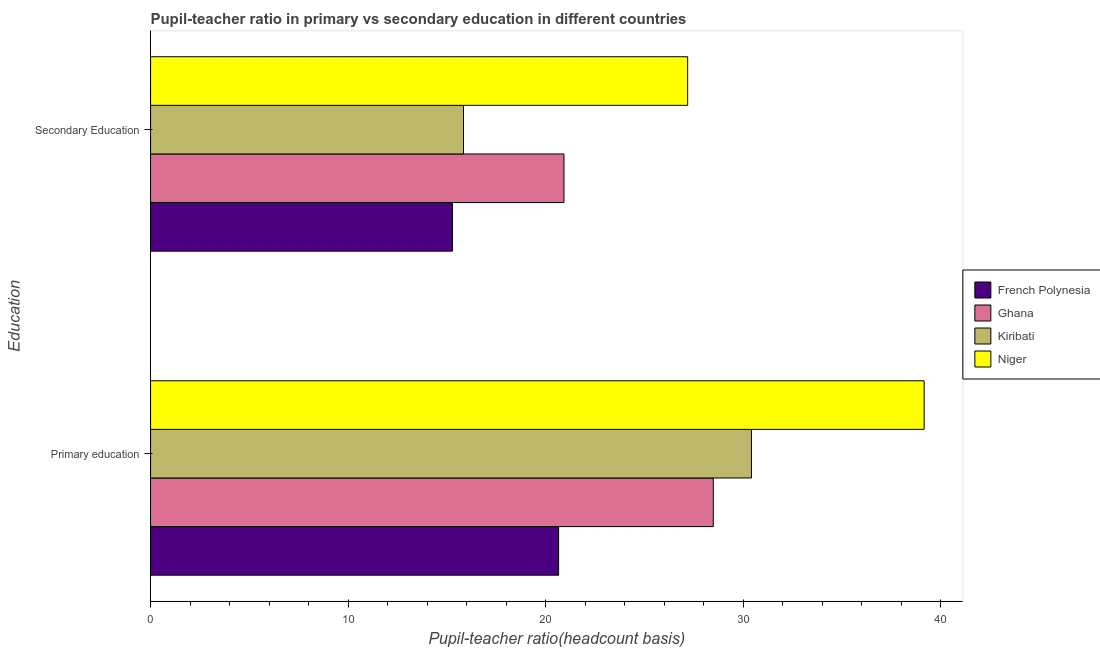How many groups of bars are there?
Provide a short and direct response. 2. Are the number of bars on each tick of the Y-axis equal?
Provide a short and direct response. Yes. How many bars are there on the 1st tick from the top?
Make the answer very short. 4. How many bars are there on the 2nd tick from the bottom?
Give a very brief answer. 4. What is the label of the 2nd group of bars from the top?
Provide a succinct answer. Primary education. What is the pupil-teacher ratio in primary education in Niger?
Give a very brief answer. 39.17. Across all countries, what is the maximum pupil teacher ratio on secondary education?
Your answer should be compact. 27.19. Across all countries, what is the minimum pupil teacher ratio on secondary education?
Offer a terse response. 15.28. In which country was the pupil teacher ratio on secondary education maximum?
Offer a terse response. Niger. In which country was the pupil teacher ratio on secondary education minimum?
Your response must be concise. French Polynesia. What is the total pupil-teacher ratio in primary education in the graph?
Ensure brevity in your answer.  118.75. What is the difference between the pupil-teacher ratio in primary education in French Polynesia and that in Ghana?
Ensure brevity in your answer.  -7.83. What is the difference between the pupil teacher ratio on secondary education in Niger and the pupil-teacher ratio in primary education in Ghana?
Give a very brief answer. -1.3. What is the average pupil-teacher ratio in primary education per country?
Ensure brevity in your answer.  29.69. What is the difference between the pupil-teacher ratio in primary education and pupil teacher ratio on secondary education in Kiribati?
Give a very brief answer. 14.58. What is the ratio of the pupil teacher ratio on secondary education in French Polynesia to that in Niger?
Offer a terse response. 0.56. Is the pupil-teacher ratio in primary education in Kiribati less than that in Niger?
Offer a very short reply. Yes. What does the 1st bar from the bottom in Secondary Education represents?
Give a very brief answer. French Polynesia. What is the difference between two consecutive major ticks on the X-axis?
Offer a very short reply. 10. How many legend labels are there?
Provide a succinct answer. 4. How are the legend labels stacked?
Make the answer very short. Vertical. What is the title of the graph?
Offer a very short reply. Pupil-teacher ratio in primary vs secondary education in different countries. Does "Europe(all income levels)" appear as one of the legend labels in the graph?
Provide a succinct answer. No. What is the label or title of the X-axis?
Make the answer very short. Pupil-teacher ratio(headcount basis). What is the label or title of the Y-axis?
Make the answer very short. Education. What is the Pupil-teacher ratio(headcount basis) in French Polynesia in Primary education?
Your answer should be compact. 20.66. What is the Pupil-teacher ratio(headcount basis) in Ghana in Primary education?
Keep it short and to the point. 28.49. What is the Pupil-teacher ratio(headcount basis) of Kiribati in Primary education?
Your answer should be very brief. 30.43. What is the Pupil-teacher ratio(headcount basis) of Niger in Primary education?
Your answer should be compact. 39.17. What is the Pupil-teacher ratio(headcount basis) of French Polynesia in Secondary Education?
Offer a very short reply. 15.28. What is the Pupil-teacher ratio(headcount basis) of Ghana in Secondary Education?
Your answer should be compact. 20.93. What is the Pupil-teacher ratio(headcount basis) in Kiribati in Secondary Education?
Offer a very short reply. 15.84. What is the Pupil-teacher ratio(headcount basis) in Niger in Secondary Education?
Offer a terse response. 27.19. Across all Education, what is the maximum Pupil-teacher ratio(headcount basis) of French Polynesia?
Provide a succinct answer. 20.66. Across all Education, what is the maximum Pupil-teacher ratio(headcount basis) in Ghana?
Your response must be concise. 28.49. Across all Education, what is the maximum Pupil-teacher ratio(headcount basis) in Kiribati?
Provide a short and direct response. 30.43. Across all Education, what is the maximum Pupil-teacher ratio(headcount basis) of Niger?
Your answer should be very brief. 39.17. Across all Education, what is the minimum Pupil-teacher ratio(headcount basis) in French Polynesia?
Offer a terse response. 15.28. Across all Education, what is the minimum Pupil-teacher ratio(headcount basis) in Ghana?
Your response must be concise. 20.93. Across all Education, what is the minimum Pupil-teacher ratio(headcount basis) of Kiribati?
Your response must be concise. 15.84. Across all Education, what is the minimum Pupil-teacher ratio(headcount basis) of Niger?
Provide a short and direct response. 27.19. What is the total Pupil-teacher ratio(headcount basis) in French Polynesia in the graph?
Your response must be concise. 35.94. What is the total Pupil-teacher ratio(headcount basis) in Ghana in the graph?
Make the answer very short. 49.42. What is the total Pupil-teacher ratio(headcount basis) of Kiribati in the graph?
Make the answer very short. 46.27. What is the total Pupil-teacher ratio(headcount basis) in Niger in the graph?
Give a very brief answer. 66.36. What is the difference between the Pupil-teacher ratio(headcount basis) of French Polynesia in Primary education and that in Secondary Education?
Your answer should be compact. 5.38. What is the difference between the Pupil-teacher ratio(headcount basis) in Ghana in Primary education and that in Secondary Education?
Provide a short and direct response. 7.56. What is the difference between the Pupil-teacher ratio(headcount basis) of Kiribati in Primary education and that in Secondary Education?
Your response must be concise. 14.58. What is the difference between the Pupil-teacher ratio(headcount basis) in Niger in Primary education and that in Secondary Education?
Your response must be concise. 11.97. What is the difference between the Pupil-teacher ratio(headcount basis) in French Polynesia in Primary education and the Pupil-teacher ratio(headcount basis) in Ghana in Secondary Education?
Your answer should be very brief. -0.27. What is the difference between the Pupil-teacher ratio(headcount basis) in French Polynesia in Primary education and the Pupil-teacher ratio(headcount basis) in Kiribati in Secondary Education?
Keep it short and to the point. 4.82. What is the difference between the Pupil-teacher ratio(headcount basis) in French Polynesia in Primary education and the Pupil-teacher ratio(headcount basis) in Niger in Secondary Education?
Your answer should be compact. -6.53. What is the difference between the Pupil-teacher ratio(headcount basis) in Ghana in Primary education and the Pupil-teacher ratio(headcount basis) in Kiribati in Secondary Education?
Your answer should be very brief. 12.65. What is the difference between the Pupil-teacher ratio(headcount basis) in Ghana in Primary education and the Pupil-teacher ratio(headcount basis) in Niger in Secondary Education?
Offer a terse response. 1.3. What is the difference between the Pupil-teacher ratio(headcount basis) in Kiribati in Primary education and the Pupil-teacher ratio(headcount basis) in Niger in Secondary Education?
Your answer should be compact. 3.23. What is the average Pupil-teacher ratio(headcount basis) of French Polynesia per Education?
Make the answer very short. 17.97. What is the average Pupil-teacher ratio(headcount basis) of Ghana per Education?
Your answer should be compact. 24.71. What is the average Pupil-teacher ratio(headcount basis) in Kiribati per Education?
Provide a short and direct response. 23.13. What is the average Pupil-teacher ratio(headcount basis) in Niger per Education?
Offer a terse response. 33.18. What is the difference between the Pupil-teacher ratio(headcount basis) in French Polynesia and Pupil-teacher ratio(headcount basis) in Ghana in Primary education?
Give a very brief answer. -7.83. What is the difference between the Pupil-teacher ratio(headcount basis) in French Polynesia and Pupil-teacher ratio(headcount basis) in Kiribati in Primary education?
Keep it short and to the point. -9.77. What is the difference between the Pupil-teacher ratio(headcount basis) in French Polynesia and Pupil-teacher ratio(headcount basis) in Niger in Primary education?
Offer a very short reply. -18.51. What is the difference between the Pupil-teacher ratio(headcount basis) of Ghana and Pupil-teacher ratio(headcount basis) of Kiribati in Primary education?
Make the answer very short. -1.93. What is the difference between the Pupil-teacher ratio(headcount basis) in Ghana and Pupil-teacher ratio(headcount basis) in Niger in Primary education?
Provide a succinct answer. -10.68. What is the difference between the Pupil-teacher ratio(headcount basis) in Kiribati and Pupil-teacher ratio(headcount basis) in Niger in Primary education?
Make the answer very short. -8.74. What is the difference between the Pupil-teacher ratio(headcount basis) of French Polynesia and Pupil-teacher ratio(headcount basis) of Ghana in Secondary Education?
Provide a succinct answer. -5.65. What is the difference between the Pupil-teacher ratio(headcount basis) of French Polynesia and Pupil-teacher ratio(headcount basis) of Kiribati in Secondary Education?
Keep it short and to the point. -0.56. What is the difference between the Pupil-teacher ratio(headcount basis) of French Polynesia and Pupil-teacher ratio(headcount basis) of Niger in Secondary Education?
Provide a short and direct response. -11.91. What is the difference between the Pupil-teacher ratio(headcount basis) in Ghana and Pupil-teacher ratio(headcount basis) in Kiribati in Secondary Education?
Your answer should be very brief. 5.09. What is the difference between the Pupil-teacher ratio(headcount basis) in Ghana and Pupil-teacher ratio(headcount basis) in Niger in Secondary Education?
Offer a terse response. -6.26. What is the difference between the Pupil-teacher ratio(headcount basis) of Kiribati and Pupil-teacher ratio(headcount basis) of Niger in Secondary Education?
Make the answer very short. -11.35. What is the ratio of the Pupil-teacher ratio(headcount basis) in French Polynesia in Primary education to that in Secondary Education?
Ensure brevity in your answer.  1.35. What is the ratio of the Pupil-teacher ratio(headcount basis) of Ghana in Primary education to that in Secondary Education?
Give a very brief answer. 1.36. What is the ratio of the Pupil-teacher ratio(headcount basis) of Kiribati in Primary education to that in Secondary Education?
Offer a very short reply. 1.92. What is the ratio of the Pupil-teacher ratio(headcount basis) of Niger in Primary education to that in Secondary Education?
Keep it short and to the point. 1.44. What is the difference between the highest and the second highest Pupil-teacher ratio(headcount basis) in French Polynesia?
Your answer should be very brief. 5.38. What is the difference between the highest and the second highest Pupil-teacher ratio(headcount basis) of Ghana?
Your answer should be very brief. 7.56. What is the difference between the highest and the second highest Pupil-teacher ratio(headcount basis) in Kiribati?
Give a very brief answer. 14.58. What is the difference between the highest and the second highest Pupil-teacher ratio(headcount basis) in Niger?
Your answer should be very brief. 11.97. What is the difference between the highest and the lowest Pupil-teacher ratio(headcount basis) in French Polynesia?
Make the answer very short. 5.38. What is the difference between the highest and the lowest Pupil-teacher ratio(headcount basis) in Ghana?
Give a very brief answer. 7.56. What is the difference between the highest and the lowest Pupil-teacher ratio(headcount basis) in Kiribati?
Your answer should be very brief. 14.58. What is the difference between the highest and the lowest Pupil-teacher ratio(headcount basis) in Niger?
Offer a very short reply. 11.97. 